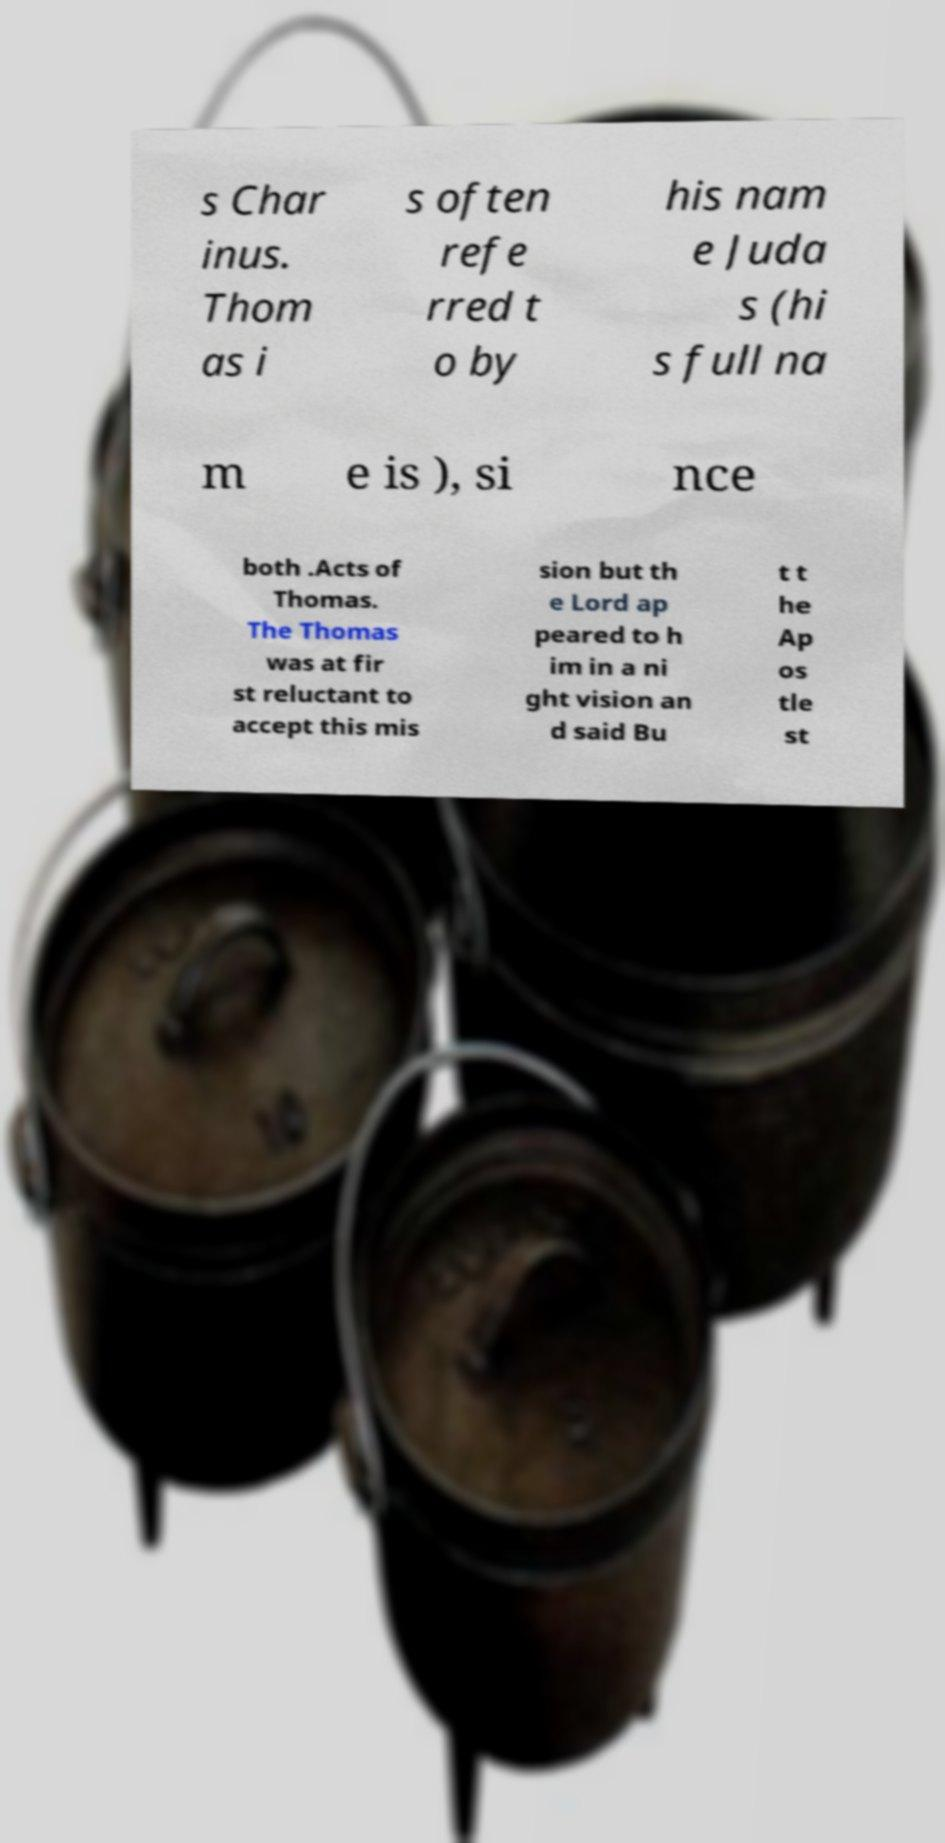Can you accurately transcribe the text from the provided image for me? s Char inus. Thom as i s often refe rred t o by his nam e Juda s (hi s full na m e is ), si nce both .Acts of Thomas. The Thomas was at fir st reluctant to accept this mis sion but th e Lord ap peared to h im in a ni ght vision an d said Bu t t he Ap os tle st 